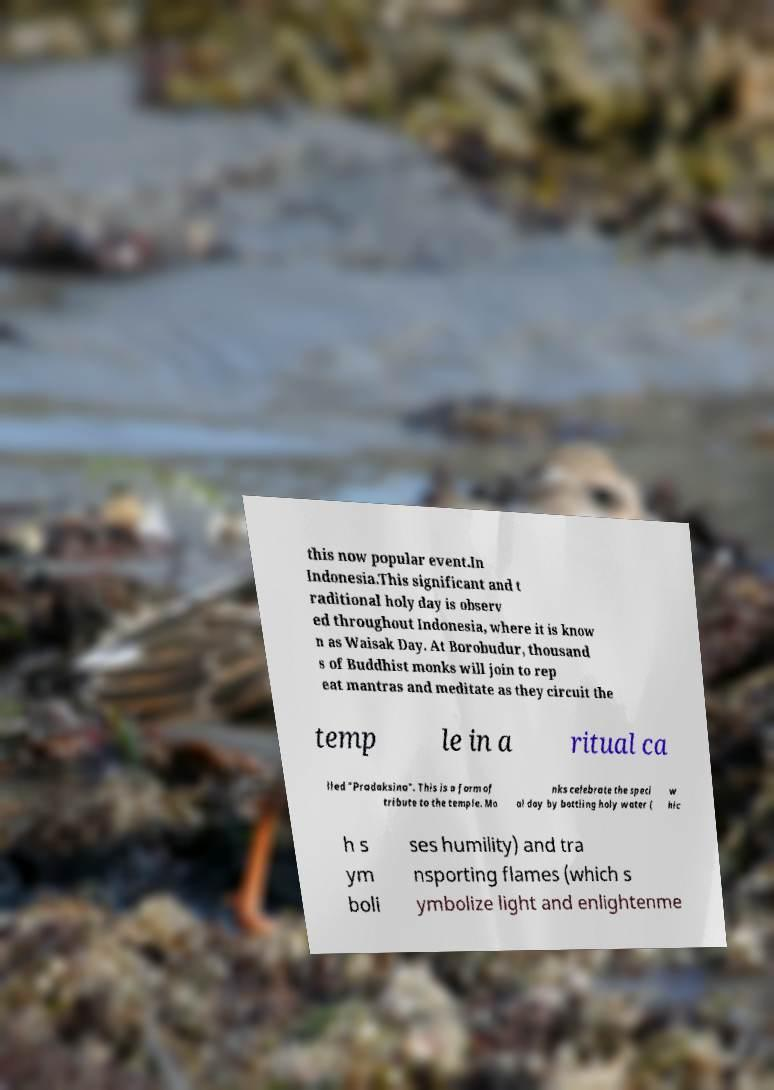There's text embedded in this image that I need extracted. Can you transcribe it verbatim? this now popular event.In Indonesia.This significant and t raditional holy day is observ ed throughout Indonesia, where it is know n as Waisak Day. At Borobudur, thousand s of Buddhist monks will join to rep eat mantras and meditate as they circuit the temp le in a ritual ca lled "Pradaksina". This is a form of tribute to the temple. Mo nks celebrate the speci al day by bottling holy water ( w hic h s ym boli ses humility) and tra nsporting flames (which s ymbolize light and enlightenme 